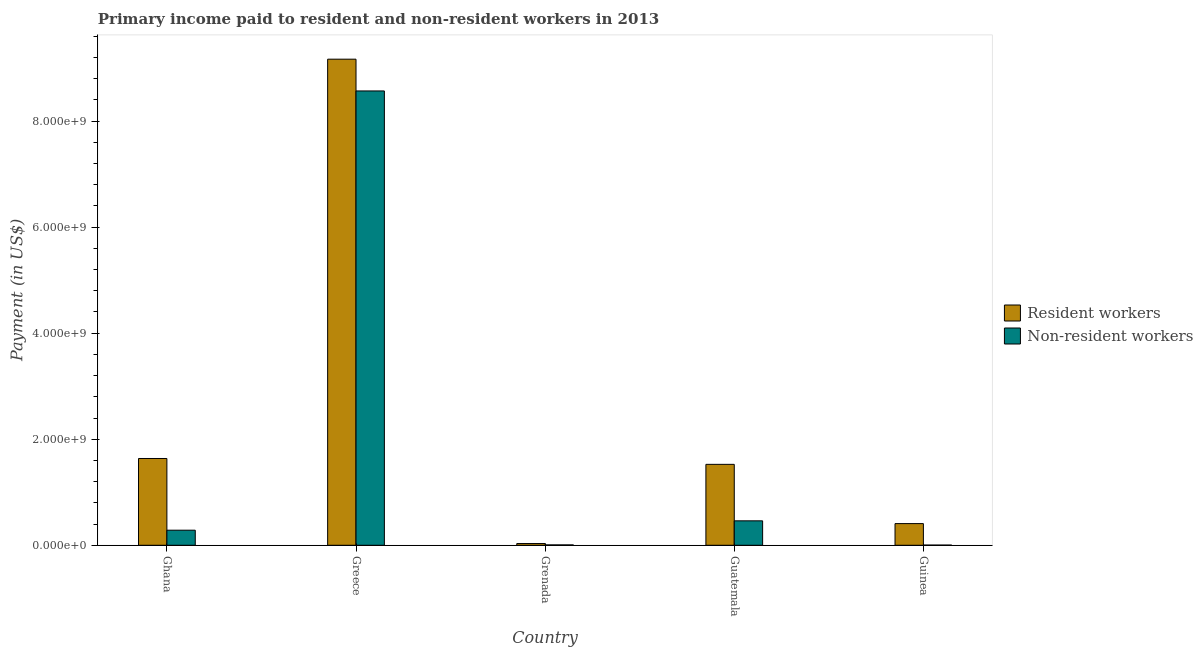How many groups of bars are there?
Your answer should be very brief. 5. How many bars are there on the 1st tick from the left?
Offer a terse response. 2. How many bars are there on the 3rd tick from the right?
Give a very brief answer. 2. What is the label of the 5th group of bars from the left?
Provide a short and direct response. Guinea. In how many cases, is the number of bars for a given country not equal to the number of legend labels?
Your answer should be very brief. 0. What is the payment made to non-resident workers in Guinea?
Your answer should be very brief. 3.64e+06. Across all countries, what is the maximum payment made to non-resident workers?
Your response must be concise. 8.57e+09. Across all countries, what is the minimum payment made to resident workers?
Give a very brief answer. 3.27e+07. In which country was the payment made to non-resident workers maximum?
Provide a short and direct response. Greece. In which country was the payment made to non-resident workers minimum?
Your response must be concise. Guinea. What is the total payment made to resident workers in the graph?
Give a very brief answer. 1.28e+1. What is the difference between the payment made to resident workers in Greece and that in Grenada?
Give a very brief answer. 9.13e+09. What is the difference between the payment made to non-resident workers in Ghana and the payment made to resident workers in Grenada?
Ensure brevity in your answer.  2.52e+08. What is the average payment made to non-resident workers per country?
Provide a short and direct response. 1.86e+09. What is the difference between the payment made to resident workers and payment made to non-resident workers in Grenada?
Provide a succinct answer. 2.57e+07. In how many countries, is the payment made to resident workers greater than 4400000000 US$?
Your response must be concise. 1. What is the ratio of the payment made to resident workers in Ghana to that in Guinea?
Give a very brief answer. 4. Is the payment made to non-resident workers in Guatemala less than that in Guinea?
Provide a succinct answer. No. Is the difference between the payment made to resident workers in Guatemala and Guinea greater than the difference between the payment made to non-resident workers in Guatemala and Guinea?
Ensure brevity in your answer.  Yes. What is the difference between the highest and the second highest payment made to resident workers?
Provide a succinct answer. 7.53e+09. What is the difference between the highest and the lowest payment made to non-resident workers?
Your answer should be very brief. 8.56e+09. Is the sum of the payment made to resident workers in Ghana and Guatemala greater than the maximum payment made to non-resident workers across all countries?
Your answer should be very brief. No. What does the 1st bar from the left in Guatemala represents?
Make the answer very short. Resident workers. What does the 1st bar from the right in Grenada represents?
Keep it short and to the point. Non-resident workers. How many countries are there in the graph?
Ensure brevity in your answer.  5. What is the difference between two consecutive major ticks on the Y-axis?
Ensure brevity in your answer.  2.00e+09. Are the values on the major ticks of Y-axis written in scientific E-notation?
Your answer should be compact. Yes. Does the graph contain any zero values?
Make the answer very short. No. Does the graph contain grids?
Ensure brevity in your answer.  No. Where does the legend appear in the graph?
Offer a terse response. Center right. How many legend labels are there?
Your answer should be compact. 2. How are the legend labels stacked?
Give a very brief answer. Vertical. What is the title of the graph?
Provide a succinct answer. Primary income paid to resident and non-resident workers in 2013. What is the label or title of the X-axis?
Provide a succinct answer. Country. What is the label or title of the Y-axis?
Your answer should be compact. Payment (in US$). What is the Payment (in US$) in Resident workers in Ghana?
Give a very brief answer. 1.64e+09. What is the Payment (in US$) in Non-resident workers in Ghana?
Your answer should be very brief. 2.84e+08. What is the Payment (in US$) of Resident workers in Greece?
Offer a terse response. 9.17e+09. What is the Payment (in US$) of Non-resident workers in Greece?
Your answer should be very brief. 8.57e+09. What is the Payment (in US$) of Resident workers in Grenada?
Provide a succinct answer. 3.27e+07. What is the Payment (in US$) in Non-resident workers in Grenada?
Provide a short and direct response. 6.99e+06. What is the Payment (in US$) of Resident workers in Guatemala?
Your answer should be compact. 1.53e+09. What is the Payment (in US$) of Non-resident workers in Guatemala?
Your answer should be compact. 4.61e+08. What is the Payment (in US$) of Resident workers in Guinea?
Provide a succinct answer. 4.09e+08. What is the Payment (in US$) in Non-resident workers in Guinea?
Your answer should be very brief. 3.64e+06. Across all countries, what is the maximum Payment (in US$) in Resident workers?
Ensure brevity in your answer.  9.17e+09. Across all countries, what is the maximum Payment (in US$) of Non-resident workers?
Offer a very short reply. 8.57e+09. Across all countries, what is the minimum Payment (in US$) in Resident workers?
Ensure brevity in your answer.  3.27e+07. Across all countries, what is the minimum Payment (in US$) of Non-resident workers?
Offer a terse response. 3.64e+06. What is the total Payment (in US$) of Resident workers in the graph?
Provide a short and direct response. 1.28e+1. What is the total Payment (in US$) in Non-resident workers in the graph?
Your answer should be very brief. 9.32e+09. What is the difference between the Payment (in US$) in Resident workers in Ghana and that in Greece?
Keep it short and to the point. -7.53e+09. What is the difference between the Payment (in US$) of Non-resident workers in Ghana and that in Greece?
Your answer should be very brief. -8.28e+09. What is the difference between the Payment (in US$) in Resident workers in Ghana and that in Grenada?
Provide a short and direct response. 1.60e+09. What is the difference between the Payment (in US$) of Non-resident workers in Ghana and that in Grenada?
Your answer should be very brief. 2.78e+08. What is the difference between the Payment (in US$) of Resident workers in Ghana and that in Guatemala?
Make the answer very short. 1.10e+08. What is the difference between the Payment (in US$) of Non-resident workers in Ghana and that in Guatemala?
Offer a very short reply. -1.76e+08. What is the difference between the Payment (in US$) in Resident workers in Ghana and that in Guinea?
Provide a short and direct response. 1.23e+09. What is the difference between the Payment (in US$) of Non-resident workers in Ghana and that in Guinea?
Make the answer very short. 2.81e+08. What is the difference between the Payment (in US$) of Resident workers in Greece and that in Grenada?
Your answer should be very brief. 9.13e+09. What is the difference between the Payment (in US$) in Non-resident workers in Greece and that in Grenada?
Your response must be concise. 8.56e+09. What is the difference between the Payment (in US$) in Resident workers in Greece and that in Guatemala?
Your answer should be compact. 7.64e+09. What is the difference between the Payment (in US$) in Non-resident workers in Greece and that in Guatemala?
Ensure brevity in your answer.  8.11e+09. What is the difference between the Payment (in US$) of Resident workers in Greece and that in Guinea?
Your answer should be very brief. 8.76e+09. What is the difference between the Payment (in US$) in Non-resident workers in Greece and that in Guinea?
Give a very brief answer. 8.56e+09. What is the difference between the Payment (in US$) of Resident workers in Grenada and that in Guatemala?
Make the answer very short. -1.49e+09. What is the difference between the Payment (in US$) of Non-resident workers in Grenada and that in Guatemala?
Ensure brevity in your answer.  -4.54e+08. What is the difference between the Payment (in US$) in Resident workers in Grenada and that in Guinea?
Your response must be concise. -3.76e+08. What is the difference between the Payment (in US$) in Non-resident workers in Grenada and that in Guinea?
Provide a short and direct response. 3.35e+06. What is the difference between the Payment (in US$) in Resident workers in Guatemala and that in Guinea?
Your answer should be very brief. 1.12e+09. What is the difference between the Payment (in US$) of Non-resident workers in Guatemala and that in Guinea?
Your answer should be very brief. 4.57e+08. What is the difference between the Payment (in US$) in Resident workers in Ghana and the Payment (in US$) in Non-resident workers in Greece?
Give a very brief answer. -6.93e+09. What is the difference between the Payment (in US$) in Resident workers in Ghana and the Payment (in US$) in Non-resident workers in Grenada?
Your answer should be very brief. 1.63e+09. What is the difference between the Payment (in US$) in Resident workers in Ghana and the Payment (in US$) in Non-resident workers in Guatemala?
Your answer should be very brief. 1.18e+09. What is the difference between the Payment (in US$) in Resident workers in Ghana and the Payment (in US$) in Non-resident workers in Guinea?
Offer a very short reply. 1.63e+09. What is the difference between the Payment (in US$) of Resident workers in Greece and the Payment (in US$) of Non-resident workers in Grenada?
Give a very brief answer. 9.16e+09. What is the difference between the Payment (in US$) in Resident workers in Greece and the Payment (in US$) in Non-resident workers in Guatemala?
Give a very brief answer. 8.71e+09. What is the difference between the Payment (in US$) in Resident workers in Greece and the Payment (in US$) in Non-resident workers in Guinea?
Ensure brevity in your answer.  9.16e+09. What is the difference between the Payment (in US$) in Resident workers in Grenada and the Payment (in US$) in Non-resident workers in Guatemala?
Your response must be concise. -4.28e+08. What is the difference between the Payment (in US$) of Resident workers in Grenada and the Payment (in US$) of Non-resident workers in Guinea?
Your answer should be very brief. 2.90e+07. What is the difference between the Payment (in US$) of Resident workers in Guatemala and the Payment (in US$) of Non-resident workers in Guinea?
Your answer should be very brief. 1.52e+09. What is the average Payment (in US$) in Resident workers per country?
Offer a terse response. 2.55e+09. What is the average Payment (in US$) in Non-resident workers per country?
Offer a very short reply. 1.86e+09. What is the difference between the Payment (in US$) of Resident workers and Payment (in US$) of Non-resident workers in Ghana?
Provide a succinct answer. 1.35e+09. What is the difference between the Payment (in US$) in Resident workers and Payment (in US$) in Non-resident workers in Greece?
Keep it short and to the point. 5.99e+08. What is the difference between the Payment (in US$) in Resident workers and Payment (in US$) in Non-resident workers in Grenada?
Make the answer very short. 2.57e+07. What is the difference between the Payment (in US$) in Resident workers and Payment (in US$) in Non-resident workers in Guatemala?
Your answer should be compact. 1.07e+09. What is the difference between the Payment (in US$) in Resident workers and Payment (in US$) in Non-resident workers in Guinea?
Your response must be concise. 4.05e+08. What is the ratio of the Payment (in US$) in Resident workers in Ghana to that in Greece?
Make the answer very short. 0.18. What is the ratio of the Payment (in US$) in Non-resident workers in Ghana to that in Greece?
Make the answer very short. 0.03. What is the ratio of the Payment (in US$) of Resident workers in Ghana to that in Grenada?
Your answer should be compact. 50.08. What is the ratio of the Payment (in US$) in Non-resident workers in Ghana to that in Grenada?
Provide a short and direct response. 40.69. What is the ratio of the Payment (in US$) in Resident workers in Ghana to that in Guatemala?
Ensure brevity in your answer.  1.07. What is the ratio of the Payment (in US$) of Non-resident workers in Ghana to that in Guatemala?
Offer a very short reply. 0.62. What is the ratio of the Payment (in US$) in Resident workers in Ghana to that in Guinea?
Give a very brief answer. 4. What is the ratio of the Payment (in US$) in Non-resident workers in Ghana to that in Guinea?
Ensure brevity in your answer.  78.16. What is the ratio of the Payment (in US$) in Resident workers in Greece to that in Grenada?
Provide a short and direct response. 280.49. What is the ratio of the Payment (in US$) in Non-resident workers in Greece to that in Grenada?
Make the answer very short. 1225.19. What is the ratio of the Payment (in US$) of Resident workers in Greece to that in Guatemala?
Provide a short and direct response. 6.01. What is the ratio of the Payment (in US$) of Non-resident workers in Greece to that in Guatemala?
Offer a terse response. 18.59. What is the ratio of the Payment (in US$) in Resident workers in Greece to that in Guinea?
Ensure brevity in your answer.  22.42. What is the ratio of the Payment (in US$) of Non-resident workers in Greece to that in Guinea?
Provide a succinct answer. 2353.7. What is the ratio of the Payment (in US$) of Resident workers in Grenada to that in Guatemala?
Your answer should be compact. 0.02. What is the ratio of the Payment (in US$) of Non-resident workers in Grenada to that in Guatemala?
Ensure brevity in your answer.  0.02. What is the ratio of the Payment (in US$) of Resident workers in Grenada to that in Guinea?
Your response must be concise. 0.08. What is the ratio of the Payment (in US$) of Non-resident workers in Grenada to that in Guinea?
Offer a very short reply. 1.92. What is the ratio of the Payment (in US$) of Resident workers in Guatemala to that in Guinea?
Ensure brevity in your answer.  3.73. What is the ratio of the Payment (in US$) of Non-resident workers in Guatemala to that in Guinea?
Give a very brief answer. 126.63. What is the difference between the highest and the second highest Payment (in US$) of Resident workers?
Ensure brevity in your answer.  7.53e+09. What is the difference between the highest and the second highest Payment (in US$) of Non-resident workers?
Your response must be concise. 8.11e+09. What is the difference between the highest and the lowest Payment (in US$) in Resident workers?
Give a very brief answer. 9.13e+09. What is the difference between the highest and the lowest Payment (in US$) in Non-resident workers?
Your response must be concise. 8.56e+09. 